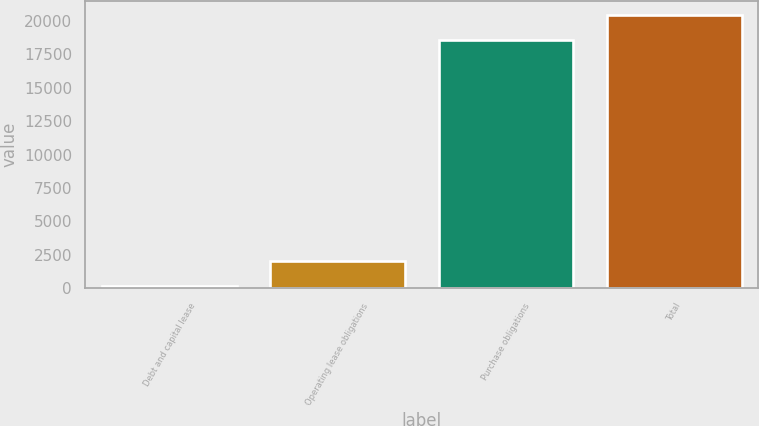Convert chart. <chart><loc_0><loc_0><loc_500><loc_500><bar_chart><fcel>Debt and capital lease<fcel>Operating lease obligations<fcel>Purchase obligations<fcel>Total<nl><fcel>161<fcel>2055.1<fcel>18582<fcel>20476.1<nl></chart> 